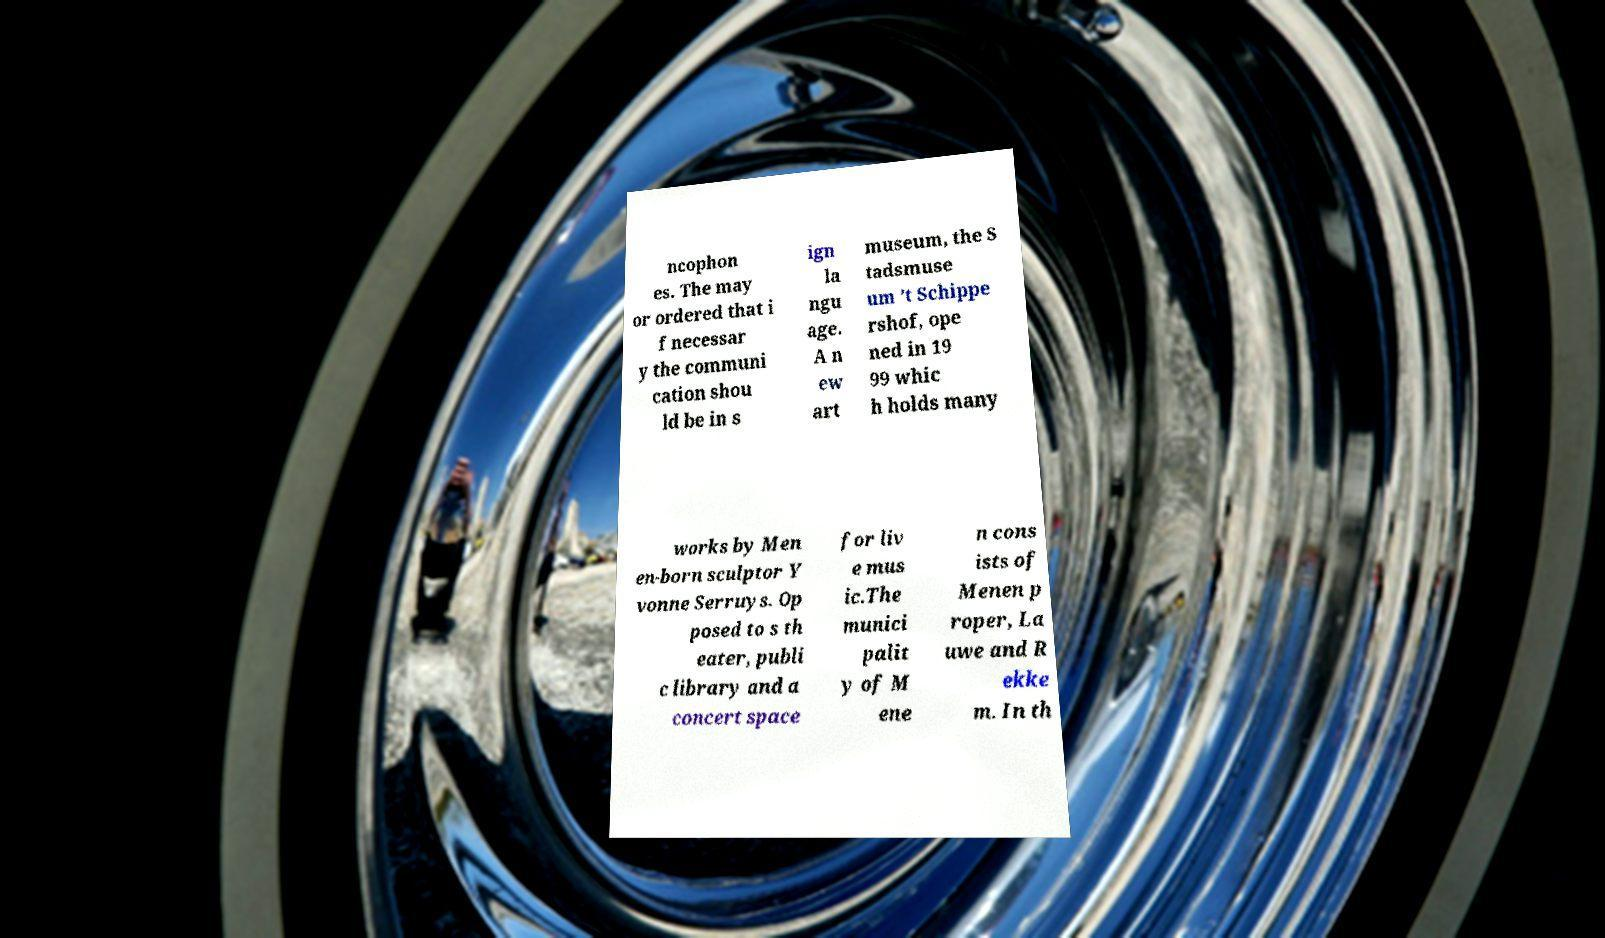Please identify and transcribe the text found in this image. ncophon es. The may or ordered that i f necessar y the communi cation shou ld be in s ign la ngu age. A n ew art museum, the S tadsmuse um ’t Schippe rshof, ope ned in 19 99 whic h holds many works by Men en-born sculptor Y vonne Serruys. Op posed to s th eater, publi c library and a concert space for liv e mus ic.The munici palit y of M ene n cons ists of Menen p roper, La uwe and R ekke m. In th 